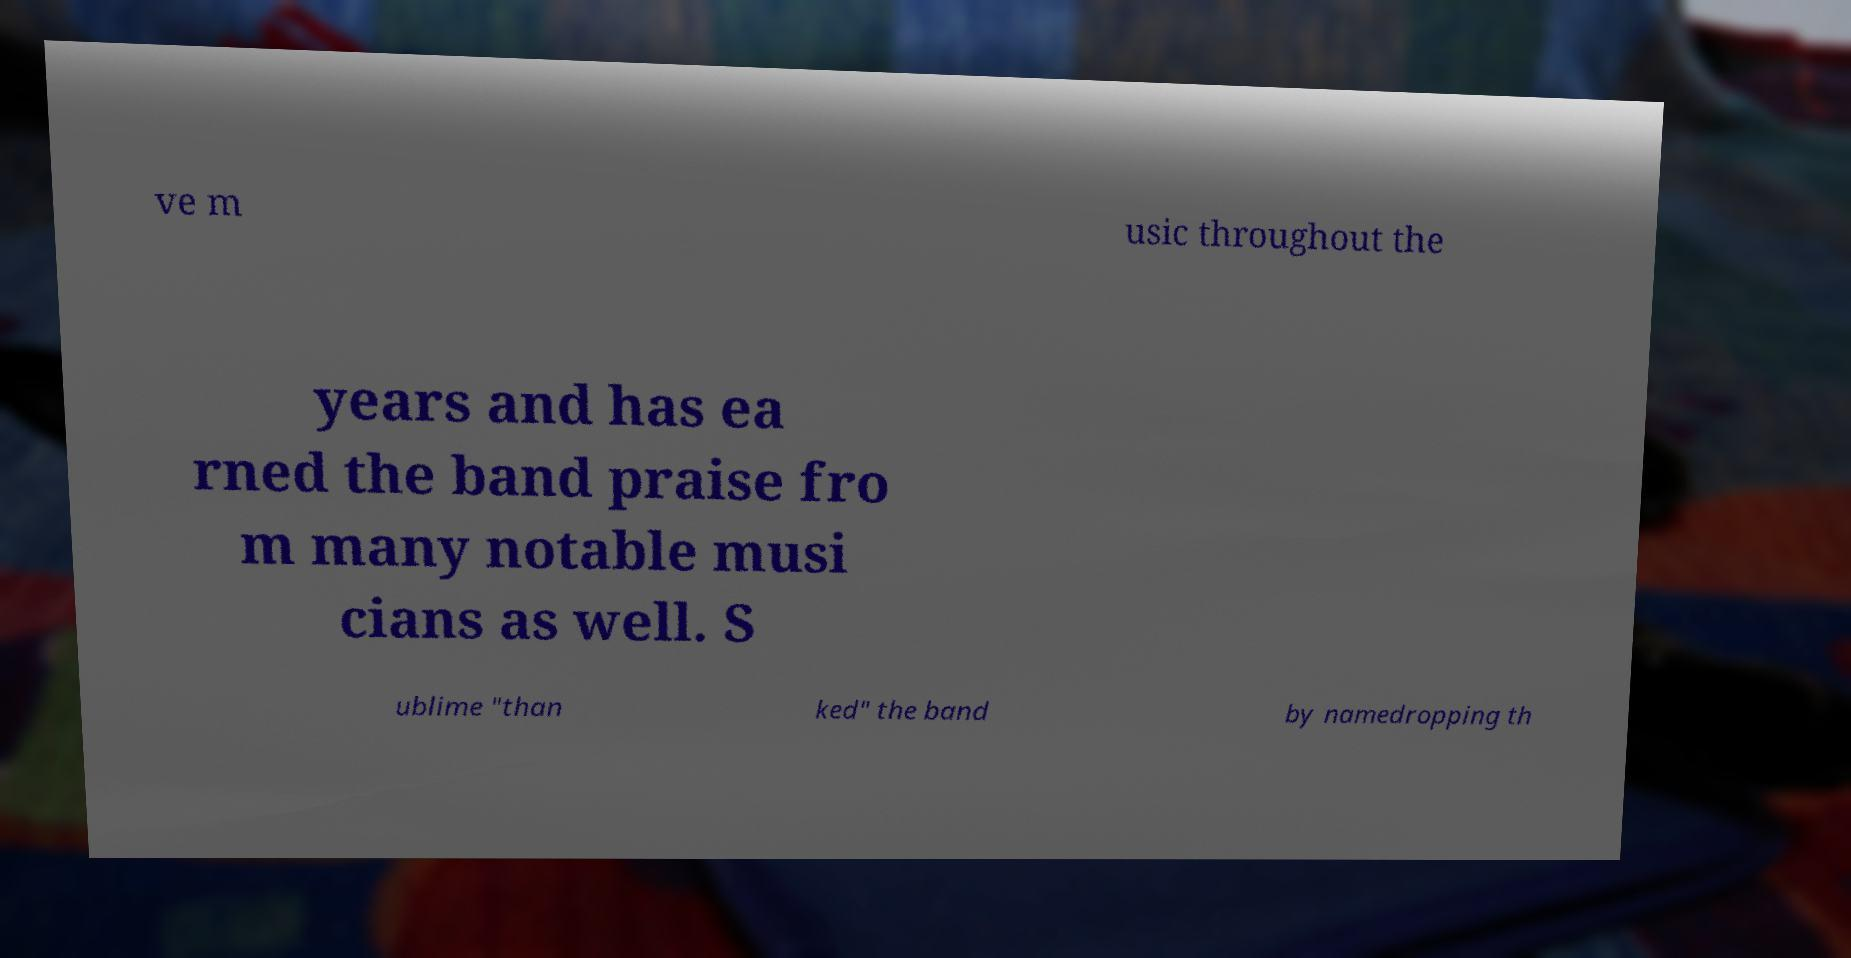Please identify and transcribe the text found in this image. ve m usic throughout the years and has ea rned the band praise fro m many notable musi cians as well. S ublime "than ked" the band by namedropping th 